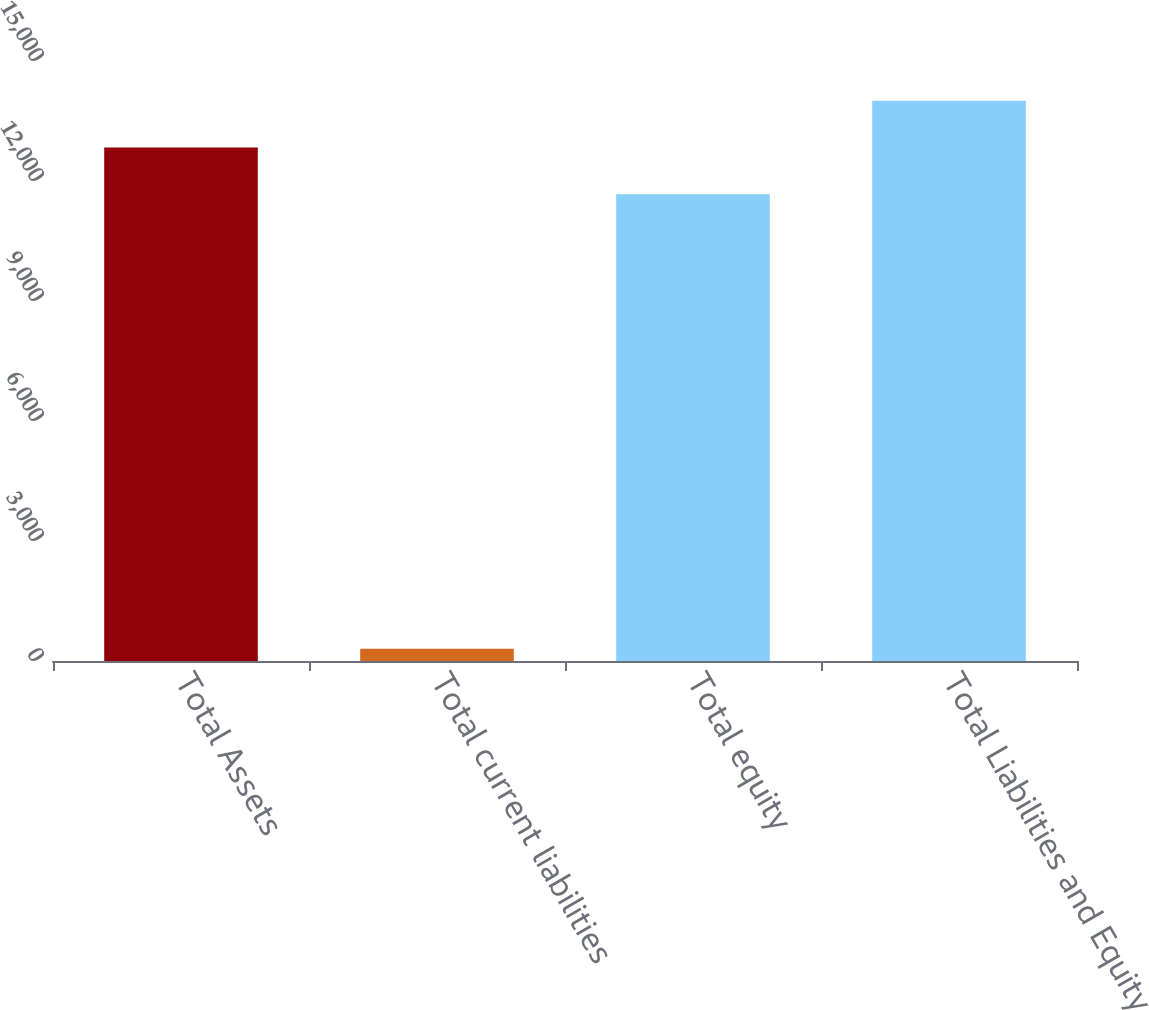Convert chart to OTSL. <chart><loc_0><loc_0><loc_500><loc_500><bar_chart><fcel>Total Assets<fcel>Total current liabilities<fcel>Total equity<fcel>Total Liabilities and Equity<nl><fcel>12836.9<fcel>303.8<fcel>11669.9<fcel>14003.9<nl></chart> 